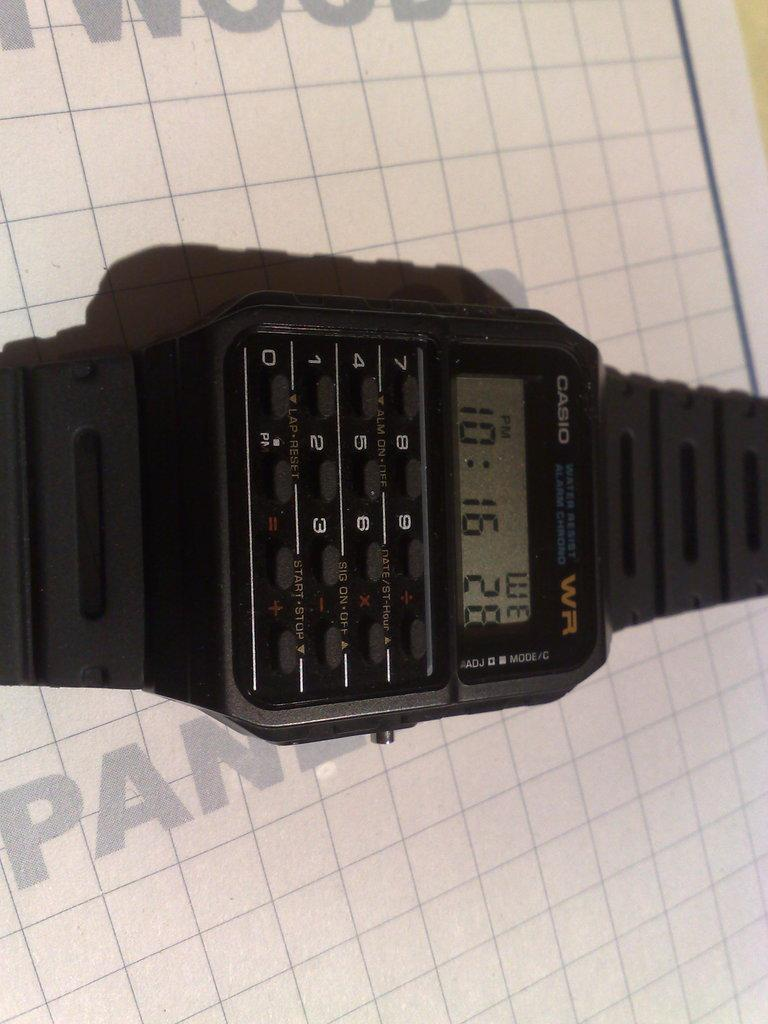<image>
Summarize the visual content of the image. A Casio watch shows the time at "10:16". 